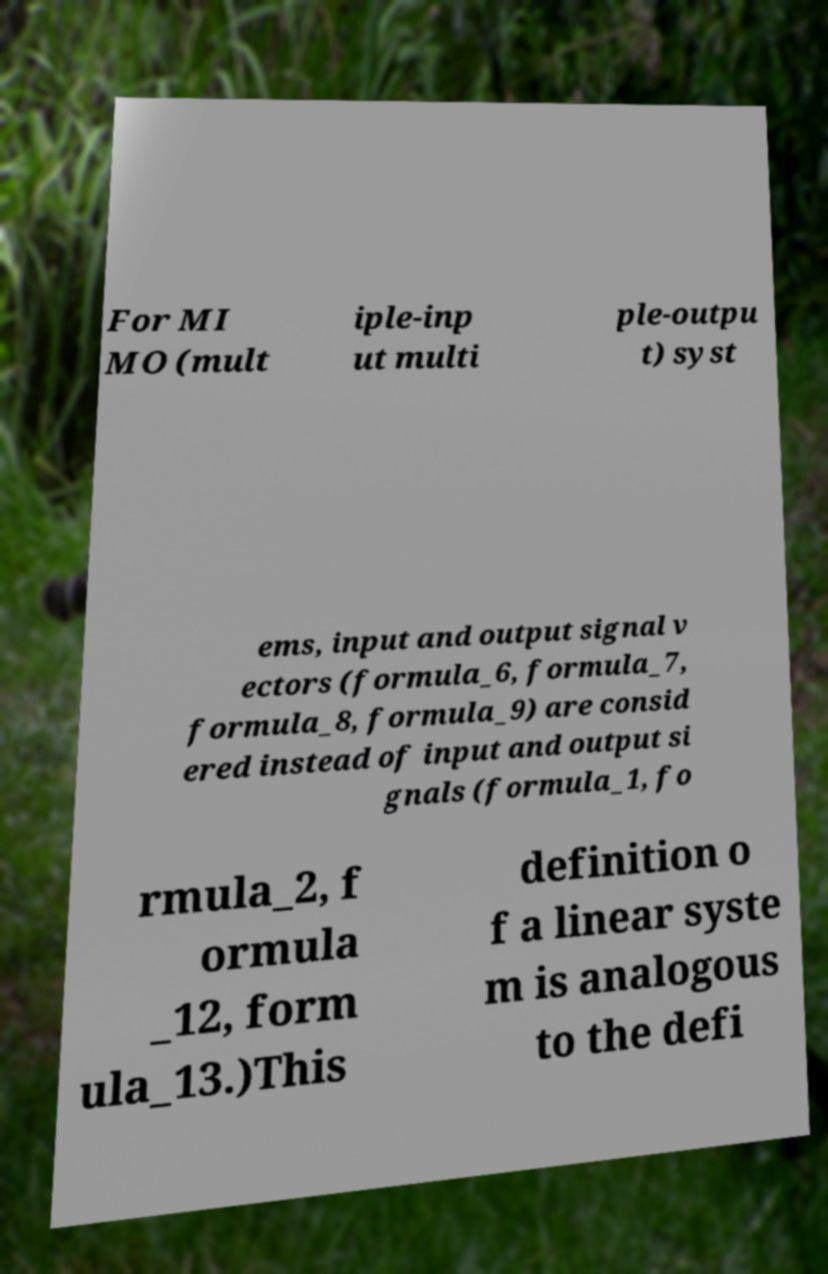Please read and relay the text visible in this image. What does it say? For MI MO (mult iple-inp ut multi ple-outpu t) syst ems, input and output signal v ectors (formula_6, formula_7, formula_8, formula_9) are consid ered instead of input and output si gnals (formula_1, fo rmula_2, f ormula _12, form ula_13.)This definition o f a linear syste m is analogous to the defi 